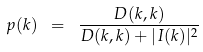<formula> <loc_0><loc_0><loc_500><loc_500>p ( k ) \ = \ \frac { D ( k , k ) } { D ( k , k ) + | I ( k ) | ^ { 2 } }</formula> 